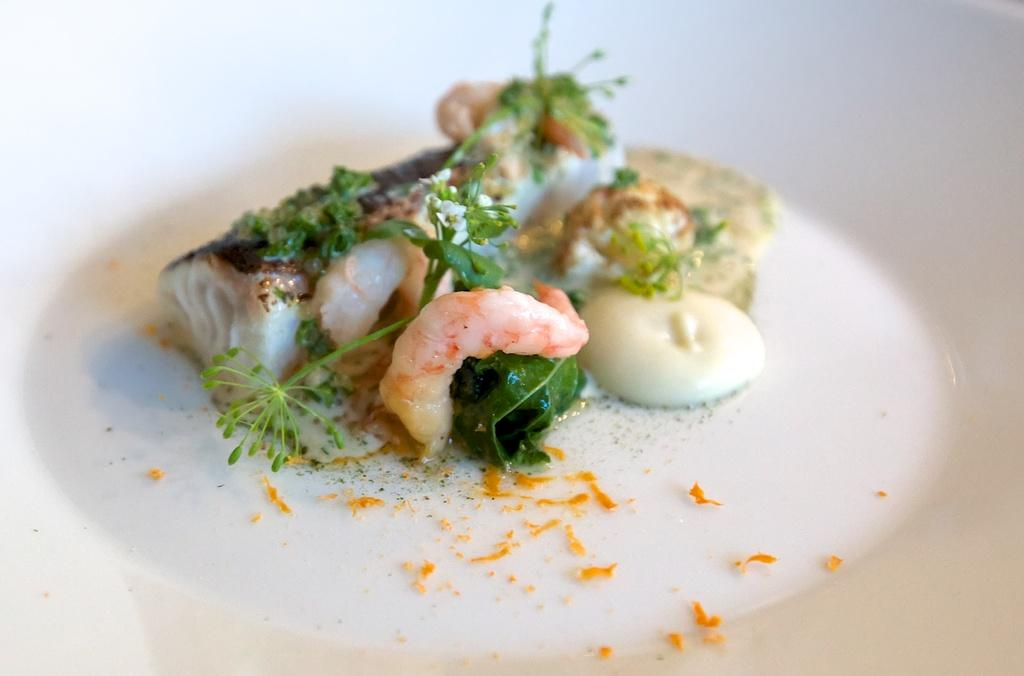What type of seafood can be seen in the image? There are prawns and fish in the image. What other ingredients are present in the image? There are eggs and curry leaves in the image. What color is the plate containing the food? The plate containing the food is white. What is the color of the background in the image? The background of the image is white. How many celery sticks are present in the image? There is no celery present in the image. What type of paste is being used in the dish shown in the image? The image does not provide information about any paste being used in the dish. 